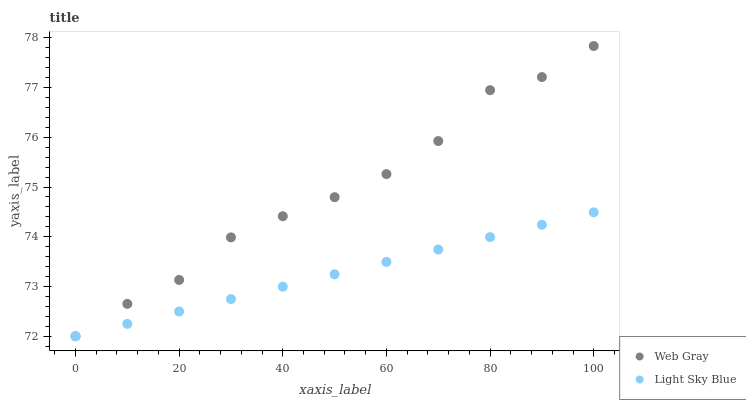Does Light Sky Blue have the minimum area under the curve?
Answer yes or no. Yes. Does Web Gray have the maximum area under the curve?
Answer yes or no. Yes. Does Light Sky Blue have the maximum area under the curve?
Answer yes or no. No. Is Light Sky Blue the smoothest?
Answer yes or no. Yes. Is Web Gray the roughest?
Answer yes or no. Yes. Is Light Sky Blue the roughest?
Answer yes or no. No. Does Web Gray have the lowest value?
Answer yes or no. Yes. Does Web Gray have the highest value?
Answer yes or no. Yes. Does Light Sky Blue have the highest value?
Answer yes or no. No. Does Web Gray intersect Light Sky Blue?
Answer yes or no. Yes. Is Web Gray less than Light Sky Blue?
Answer yes or no. No. Is Web Gray greater than Light Sky Blue?
Answer yes or no. No. 